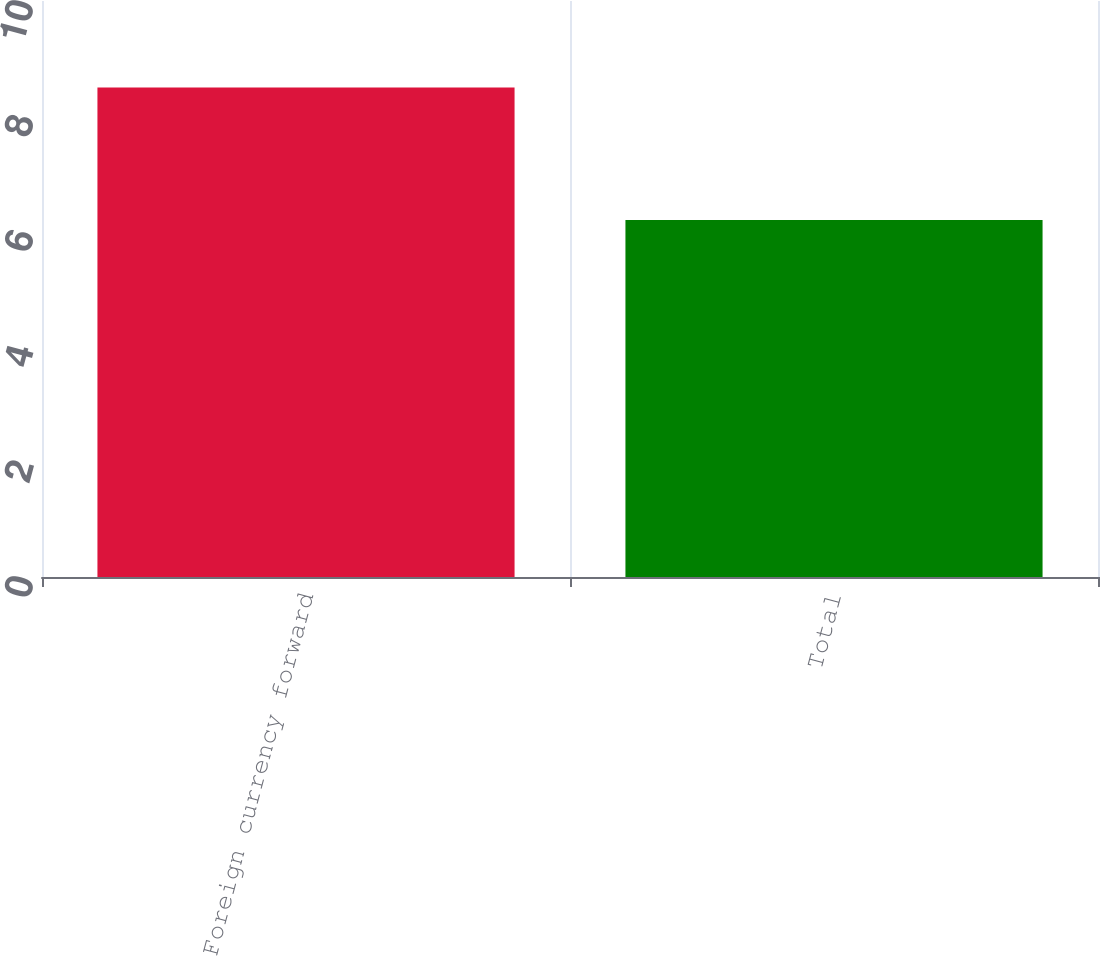Convert chart. <chart><loc_0><loc_0><loc_500><loc_500><bar_chart><fcel>Foreign currency forward<fcel>Total<nl><fcel>8.5<fcel>6.2<nl></chart> 